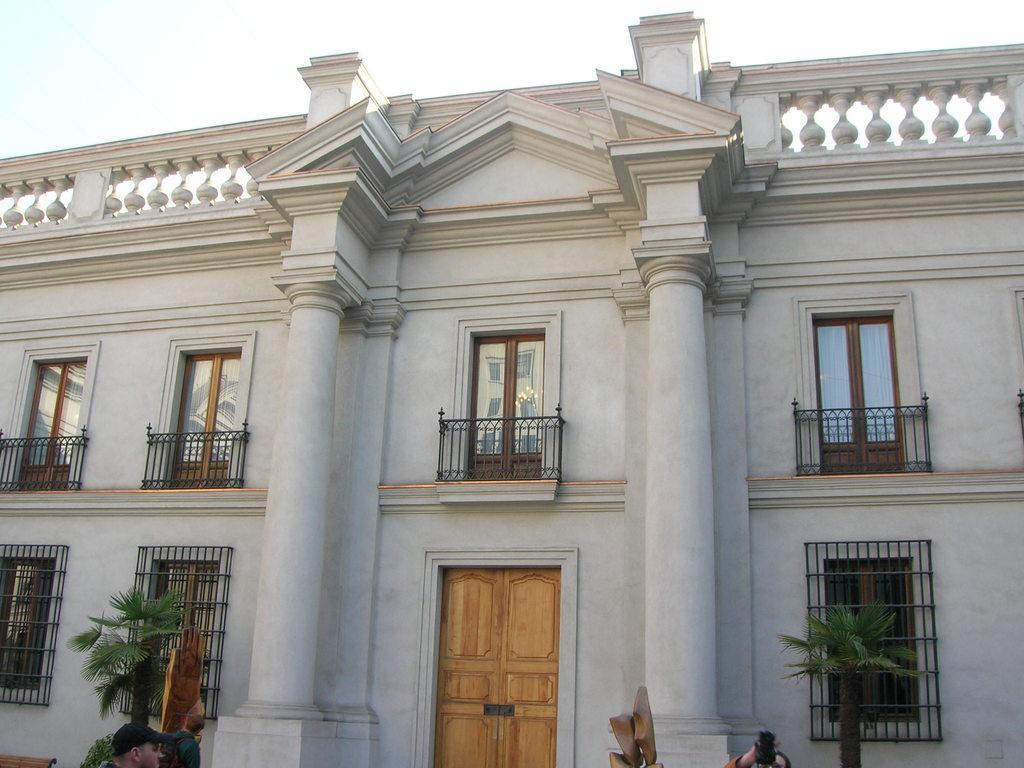In one or two sentences, can you explain what this image depicts? In this image there are people, building with windows and door , plants, and in the background there is sky. 